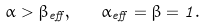Convert formula to latex. <formula><loc_0><loc_0><loc_500><loc_500>\alpha > \beta _ { e f f } , \quad \alpha _ { e f f } = \beta = 1 .</formula> 